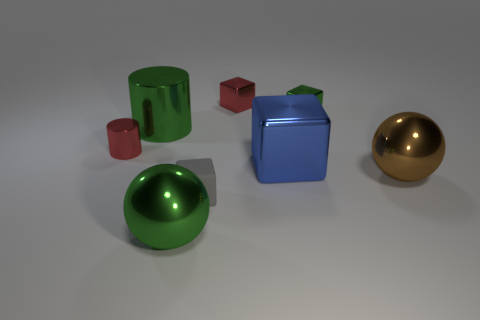Add 1 large green blocks. How many objects exist? 9 Subtract all cylinders. How many objects are left? 6 Subtract all metallic cylinders. Subtract all green shiny cylinders. How many objects are left? 5 Add 1 large green objects. How many large green objects are left? 3 Add 3 gray cubes. How many gray cubes exist? 4 Subtract 0 yellow cubes. How many objects are left? 8 